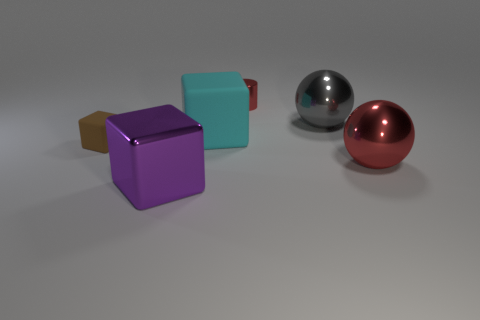What is the material of the big cyan object that is the same shape as the brown rubber object? rubber 